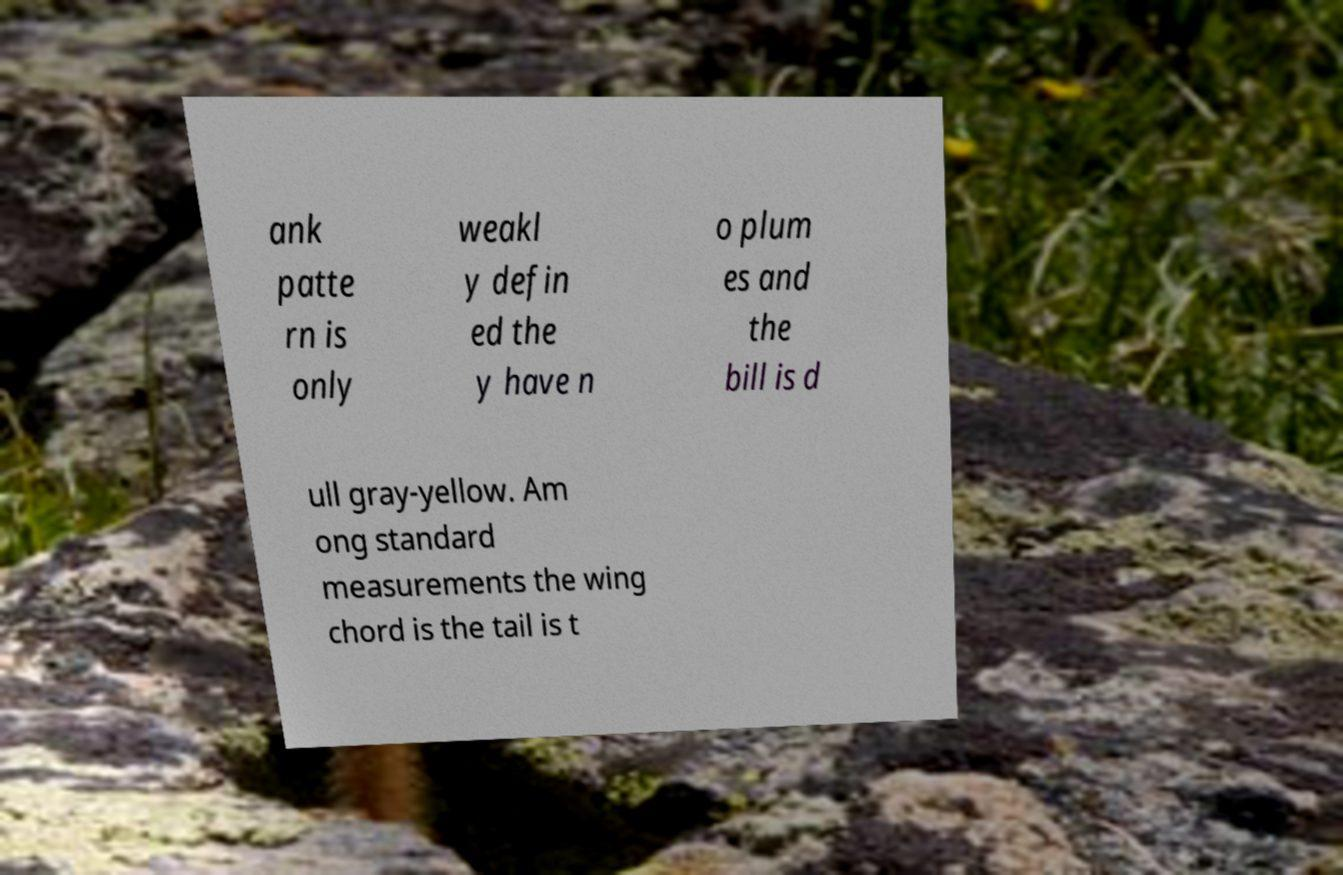Please read and relay the text visible in this image. What does it say? ank patte rn is only weakl y defin ed the y have n o plum es and the bill is d ull gray-yellow. Am ong standard measurements the wing chord is the tail is t 